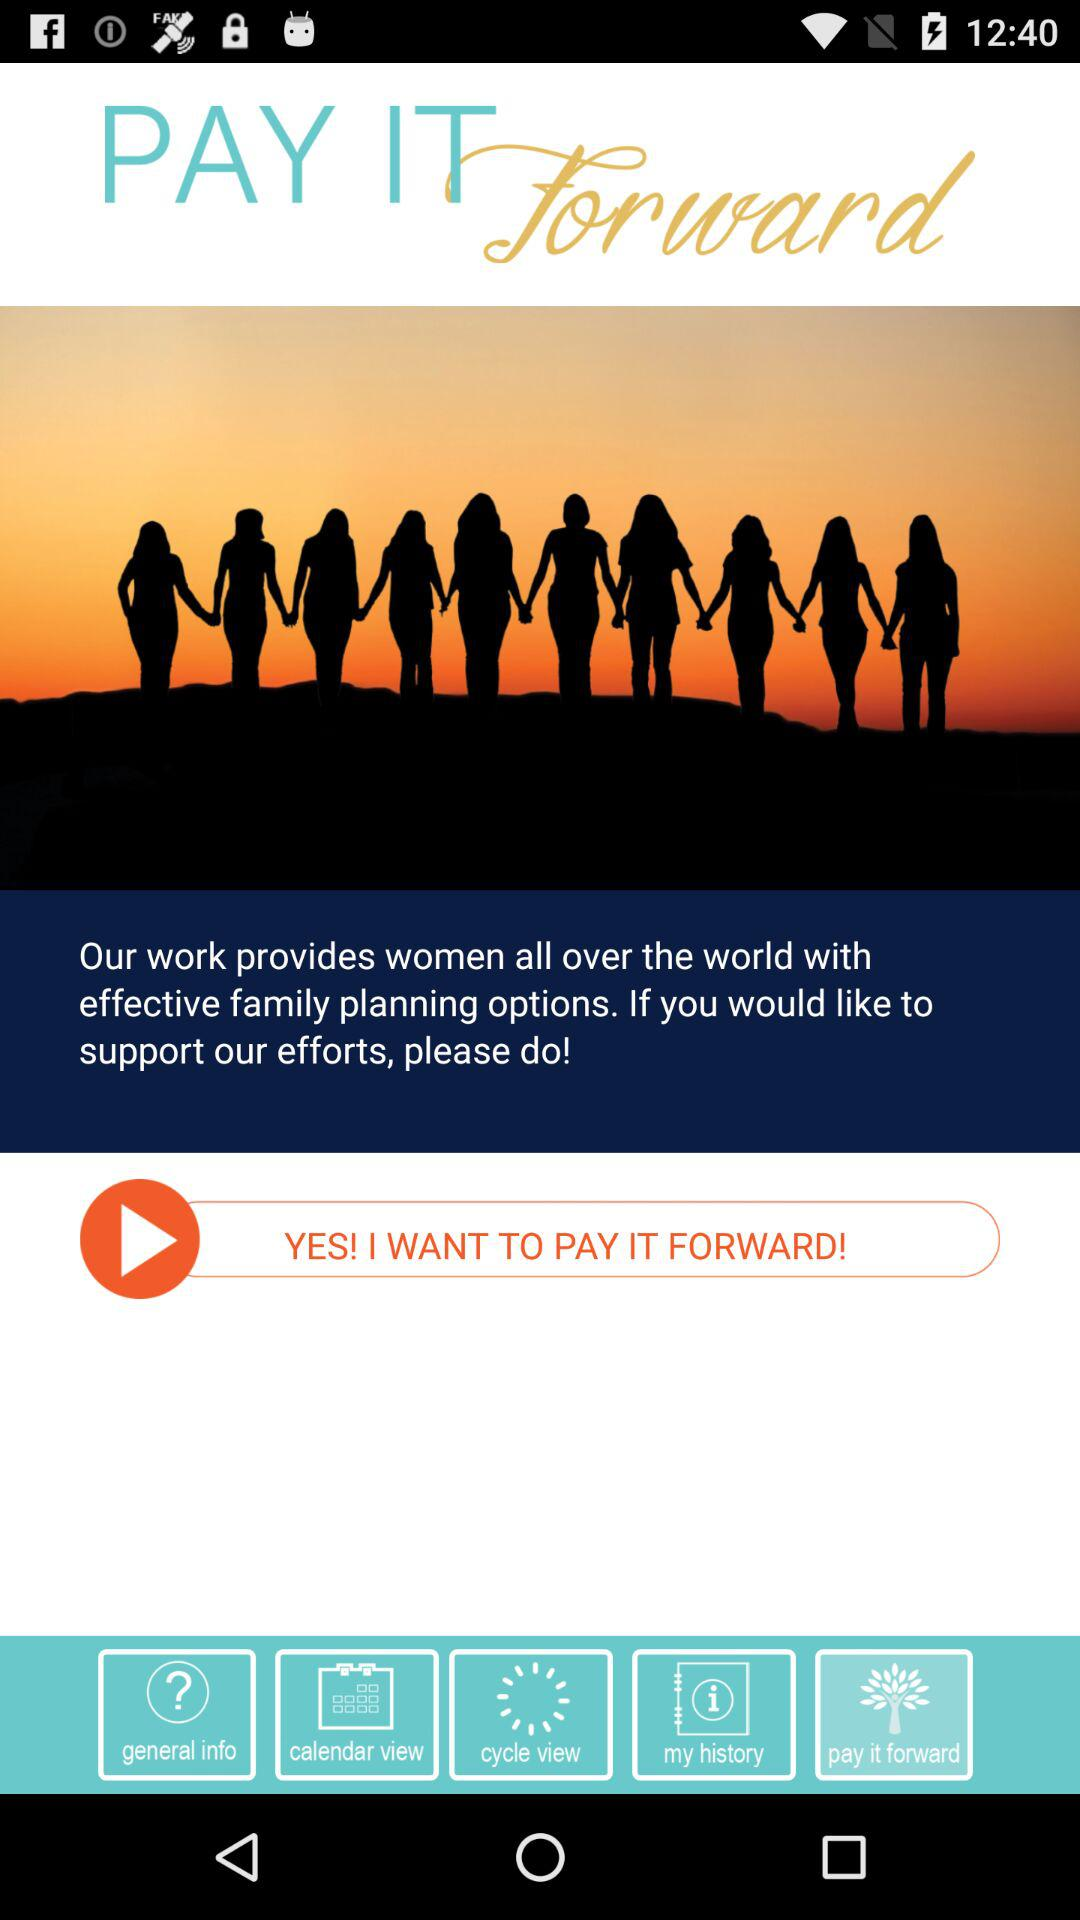What is the name of the application? The name of the application is "PAY IT Forward". 